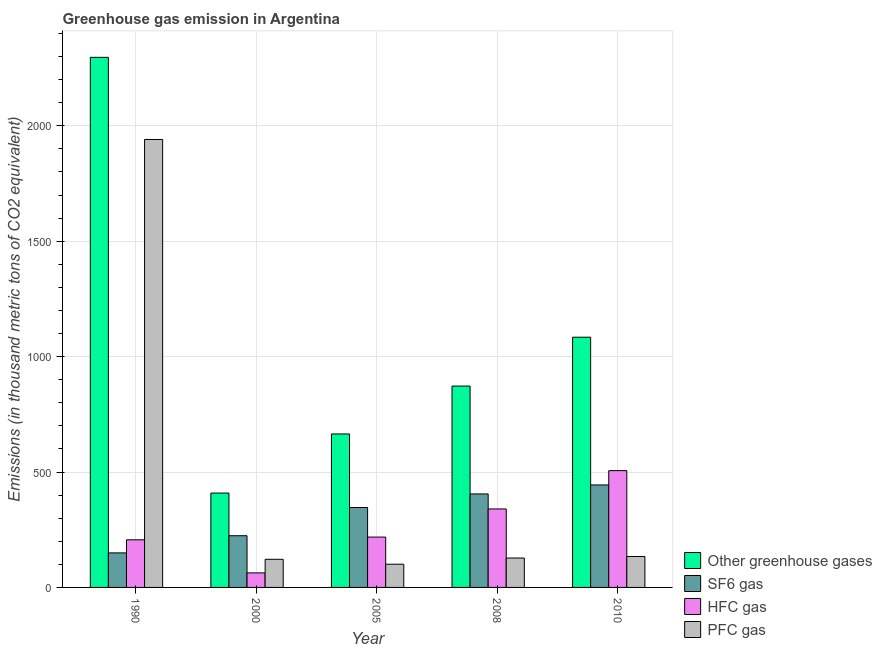How many different coloured bars are there?
Keep it short and to the point. 4. How many groups of bars are there?
Keep it short and to the point. 5. Are the number of bars per tick equal to the number of legend labels?
Your answer should be compact. Yes. What is the label of the 1st group of bars from the left?
Offer a terse response. 1990. In how many cases, is the number of bars for a given year not equal to the number of legend labels?
Your answer should be compact. 0. What is the emission of greenhouse gases in 2005?
Offer a terse response. 664.9. Across all years, what is the maximum emission of greenhouse gases?
Offer a very short reply. 2296.5. Across all years, what is the minimum emission of hfc gas?
Offer a terse response. 63. In which year was the emission of hfc gas maximum?
Provide a short and direct response. 2010. What is the total emission of sf6 gas in the graph?
Your response must be concise. 1568.8. What is the difference between the emission of pfc gas in 1990 and that in 2000?
Your answer should be very brief. 1818.8. What is the difference between the emission of sf6 gas in 2005 and the emission of greenhouse gases in 2008?
Your answer should be very brief. -58.8. What is the average emission of greenhouse gases per year?
Your response must be concise. 1065.32. In how many years, is the emission of sf6 gas greater than 2000 thousand metric tons?
Your response must be concise. 0. What is the ratio of the emission of sf6 gas in 1990 to that in 2005?
Your answer should be compact. 0.43. What is the difference between the highest and the second highest emission of pfc gas?
Offer a terse response. 1806.6. What is the difference between the highest and the lowest emission of greenhouse gases?
Your response must be concise. 1887.7. What does the 4th bar from the left in 2005 represents?
Your answer should be compact. PFC gas. What does the 3rd bar from the right in 2010 represents?
Your answer should be very brief. SF6 gas. Is it the case that in every year, the sum of the emission of greenhouse gases and emission of sf6 gas is greater than the emission of hfc gas?
Ensure brevity in your answer.  Yes. How many bars are there?
Your answer should be very brief. 20. Does the graph contain grids?
Provide a short and direct response. Yes. Where does the legend appear in the graph?
Offer a very short reply. Bottom right. How many legend labels are there?
Ensure brevity in your answer.  4. How are the legend labels stacked?
Offer a terse response. Vertical. What is the title of the graph?
Offer a very short reply. Greenhouse gas emission in Argentina. Does "Second 20% of population" appear as one of the legend labels in the graph?
Your answer should be very brief. No. What is the label or title of the X-axis?
Provide a succinct answer. Year. What is the label or title of the Y-axis?
Ensure brevity in your answer.  Emissions (in thousand metric tons of CO2 equivalent). What is the Emissions (in thousand metric tons of CO2 equivalent) in Other greenhouse gases in 1990?
Your answer should be compact. 2296.5. What is the Emissions (in thousand metric tons of CO2 equivalent) of SF6 gas in 1990?
Provide a short and direct response. 149.6. What is the Emissions (in thousand metric tons of CO2 equivalent) of HFC gas in 1990?
Provide a succinct answer. 206.3. What is the Emissions (in thousand metric tons of CO2 equivalent) of PFC gas in 1990?
Your answer should be very brief. 1940.6. What is the Emissions (in thousand metric tons of CO2 equivalent) of Other greenhouse gases in 2000?
Offer a very short reply. 408.8. What is the Emissions (in thousand metric tons of CO2 equivalent) in SF6 gas in 2000?
Your answer should be very brief. 224. What is the Emissions (in thousand metric tons of CO2 equivalent) in HFC gas in 2000?
Your response must be concise. 63. What is the Emissions (in thousand metric tons of CO2 equivalent) of PFC gas in 2000?
Your response must be concise. 121.8. What is the Emissions (in thousand metric tons of CO2 equivalent) in Other greenhouse gases in 2005?
Offer a very short reply. 664.9. What is the Emissions (in thousand metric tons of CO2 equivalent) of SF6 gas in 2005?
Offer a very short reply. 346.2. What is the Emissions (in thousand metric tons of CO2 equivalent) in HFC gas in 2005?
Make the answer very short. 218.1. What is the Emissions (in thousand metric tons of CO2 equivalent) in PFC gas in 2005?
Offer a very short reply. 100.6. What is the Emissions (in thousand metric tons of CO2 equivalent) of Other greenhouse gases in 2008?
Your response must be concise. 872.4. What is the Emissions (in thousand metric tons of CO2 equivalent) in SF6 gas in 2008?
Your answer should be compact. 405. What is the Emissions (in thousand metric tons of CO2 equivalent) of HFC gas in 2008?
Provide a succinct answer. 340. What is the Emissions (in thousand metric tons of CO2 equivalent) in PFC gas in 2008?
Provide a succinct answer. 127.4. What is the Emissions (in thousand metric tons of CO2 equivalent) of Other greenhouse gases in 2010?
Your answer should be compact. 1084. What is the Emissions (in thousand metric tons of CO2 equivalent) of SF6 gas in 2010?
Offer a terse response. 444. What is the Emissions (in thousand metric tons of CO2 equivalent) of HFC gas in 2010?
Keep it short and to the point. 506. What is the Emissions (in thousand metric tons of CO2 equivalent) of PFC gas in 2010?
Provide a short and direct response. 134. Across all years, what is the maximum Emissions (in thousand metric tons of CO2 equivalent) in Other greenhouse gases?
Offer a very short reply. 2296.5. Across all years, what is the maximum Emissions (in thousand metric tons of CO2 equivalent) in SF6 gas?
Give a very brief answer. 444. Across all years, what is the maximum Emissions (in thousand metric tons of CO2 equivalent) of HFC gas?
Your response must be concise. 506. Across all years, what is the maximum Emissions (in thousand metric tons of CO2 equivalent) of PFC gas?
Your answer should be very brief. 1940.6. Across all years, what is the minimum Emissions (in thousand metric tons of CO2 equivalent) in Other greenhouse gases?
Keep it short and to the point. 408.8. Across all years, what is the minimum Emissions (in thousand metric tons of CO2 equivalent) of SF6 gas?
Your response must be concise. 149.6. Across all years, what is the minimum Emissions (in thousand metric tons of CO2 equivalent) of PFC gas?
Offer a very short reply. 100.6. What is the total Emissions (in thousand metric tons of CO2 equivalent) of Other greenhouse gases in the graph?
Offer a very short reply. 5326.6. What is the total Emissions (in thousand metric tons of CO2 equivalent) in SF6 gas in the graph?
Offer a terse response. 1568.8. What is the total Emissions (in thousand metric tons of CO2 equivalent) in HFC gas in the graph?
Ensure brevity in your answer.  1333.4. What is the total Emissions (in thousand metric tons of CO2 equivalent) of PFC gas in the graph?
Keep it short and to the point. 2424.4. What is the difference between the Emissions (in thousand metric tons of CO2 equivalent) of Other greenhouse gases in 1990 and that in 2000?
Offer a terse response. 1887.7. What is the difference between the Emissions (in thousand metric tons of CO2 equivalent) of SF6 gas in 1990 and that in 2000?
Keep it short and to the point. -74.4. What is the difference between the Emissions (in thousand metric tons of CO2 equivalent) in HFC gas in 1990 and that in 2000?
Your answer should be compact. 143.3. What is the difference between the Emissions (in thousand metric tons of CO2 equivalent) of PFC gas in 1990 and that in 2000?
Your answer should be compact. 1818.8. What is the difference between the Emissions (in thousand metric tons of CO2 equivalent) in Other greenhouse gases in 1990 and that in 2005?
Your answer should be very brief. 1631.6. What is the difference between the Emissions (in thousand metric tons of CO2 equivalent) of SF6 gas in 1990 and that in 2005?
Your response must be concise. -196.6. What is the difference between the Emissions (in thousand metric tons of CO2 equivalent) of PFC gas in 1990 and that in 2005?
Ensure brevity in your answer.  1840. What is the difference between the Emissions (in thousand metric tons of CO2 equivalent) of Other greenhouse gases in 1990 and that in 2008?
Offer a terse response. 1424.1. What is the difference between the Emissions (in thousand metric tons of CO2 equivalent) of SF6 gas in 1990 and that in 2008?
Make the answer very short. -255.4. What is the difference between the Emissions (in thousand metric tons of CO2 equivalent) in HFC gas in 1990 and that in 2008?
Offer a terse response. -133.7. What is the difference between the Emissions (in thousand metric tons of CO2 equivalent) in PFC gas in 1990 and that in 2008?
Your answer should be very brief. 1813.2. What is the difference between the Emissions (in thousand metric tons of CO2 equivalent) of Other greenhouse gases in 1990 and that in 2010?
Ensure brevity in your answer.  1212.5. What is the difference between the Emissions (in thousand metric tons of CO2 equivalent) in SF6 gas in 1990 and that in 2010?
Ensure brevity in your answer.  -294.4. What is the difference between the Emissions (in thousand metric tons of CO2 equivalent) in HFC gas in 1990 and that in 2010?
Offer a very short reply. -299.7. What is the difference between the Emissions (in thousand metric tons of CO2 equivalent) of PFC gas in 1990 and that in 2010?
Provide a succinct answer. 1806.6. What is the difference between the Emissions (in thousand metric tons of CO2 equivalent) of Other greenhouse gases in 2000 and that in 2005?
Offer a terse response. -256.1. What is the difference between the Emissions (in thousand metric tons of CO2 equivalent) in SF6 gas in 2000 and that in 2005?
Your response must be concise. -122.2. What is the difference between the Emissions (in thousand metric tons of CO2 equivalent) in HFC gas in 2000 and that in 2005?
Ensure brevity in your answer.  -155.1. What is the difference between the Emissions (in thousand metric tons of CO2 equivalent) of PFC gas in 2000 and that in 2005?
Offer a terse response. 21.2. What is the difference between the Emissions (in thousand metric tons of CO2 equivalent) of Other greenhouse gases in 2000 and that in 2008?
Provide a succinct answer. -463.6. What is the difference between the Emissions (in thousand metric tons of CO2 equivalent) in SF6 gas in 2000 and that in 2008?
Your response must be concise. -181. What is the difference between the Emissions (in thousand metric tons of CO2 equivalent) in HFC gas in 2000 and that in 2008?
Keep it short and to the point. -277. What is the difference between the Emissions (in thousand metric tons of CO2 equivalent) in PFC gas in 2000 and that in 2008?
Provide a short and direct response. -5.6. What is the difference between the Emissions (in thousand metric tons of CO2 equivalent) in Other greenhouse gases in 2000 and that in 2010?
Your response must be concise. -675.2. What is the difference between the Emissions (in thousand metric tons of CO2 equivalent) of SF6 gas in 2000 and that in 2010?
Give a very brief answer. -220. What is the difference between the Emissions (in thousand metric tons of CO2 equivalent) in HFC gas in 2000 and that in 2010?
Your answer should be compact. -443. What is the difference between the Emissions (in thousand metric tons of CO2 equivalent) of Other greenhouse gases in 2005 and that in 2008?
Offer a terse response. -207.5. What is the difference between the Emissions (in thousand metric tons of CO2 equivalent) of SF6 gas in 2005 and that in 2008?
Your response must be concise. -58.8. What is the difference between the Emissions (in thousand metric tons of CO2 equivalent) of HFC gas in 2005 and that in 2008?
Keep it short and to the point. -121.9. What is the difference between the Emissions (in thousand metric tons of CO2 equivalent) of PFC gas in 2005 and that in 2008?
Make the answer very short. -26.8. What is the difference between the Emissions (in thousand metric tons of CO2 equivalent) in Other greenhouse gases in 2005 and that in 2010?
Your answer should be very brief. -419.1. What is the difference between the Emissions (in thousand metric tons of CO2 equivalent) in SF6 gas in 2005 and that in 2010?
Offer a terse response. -97.8. What is the difference between the Emissions (in thousand metric tons of CO2 equivalent) of HFC gas in 2005 and that in 2010?
Provide a short and direct response. -287.9. What is the difference between the Emissions (in thousand metric tons of CO2 equivalent) in PFC gas in 2005 and that in 2010?
Make the answer very short. -33.4. What is the difference between the Emissions (in thousand metric tons of CO2 equivalent) of Other greenhouse gases in 2008 and that in 2010?
Offer a very short reply. -211.6. What is the difference between the Emissions (in thousand metric tons of CO2 equivalent) in SF6 gas in 2008 and that in 2010?
Give a very brief answer. -39. What is the difference between the Emissions (in thousand metric tons of CO2 equivalent) of HFC gas in 2008 and that in 2010?
Offer a very short reply. -166. What is the difference between the Emissions (in thousand metric tons of CO2 equivalent) in Other greenhouse gases in 1990 and the Emissions (in thousand metric tons of CO2 equivalent) in SF6 gas in 2000?
Your answer should be compact. 2072.5. What is the difference between the Emissions (in thousand metric tons of CO2 equivalent) in Other greenhouse gases in 1990 and the Emissions (in thousand metric tons of CO2 equivalent) in HFC gas in 2000?
Make the answer very short. 2233.5. What is the difference between the Emissions (in thousand metric tons of CO2 equivalent) in Other greenhouse gases in 1990 and the Emissions (in thousand metric tons of CO2 equivalent) in PFC gas in 2000?
Provide a succinct answer. 2174.7. What is the difference between the Emissions (in thousand metric tons of CO2 equivalent) in SF6 gas in 1990 and the Emissions (in thousand metric tons of CO2 equivalent) in HFC gas in 2000?
Offer a terse response. 86.6. What is the difference between the Emissions (in thousand metric tons of CO2 equivalent) of SF6 gas in 1990 and the Emissions (in thousand metric tons of CO2 equivalent) of PFC gas in 2000?
Your answer should be compact. 27.8. What is the difference between the Emissions (in thousand metric tons of CO2 equivalent) of HFC gas in 1990 and the Emissions (in thousand metric tons of CO2 equivalent) of PFC gas in 2000?
Provide a succinct answer. 84.5. What is the difference between the Emissions (in thousand metric tons of CO2 equivalent) of Other greenhouse gases in 1990 and the Emissions (in thousand metric tons of CO2 equivalent) of SF6 gas in 2005?
Make the answer very short. 1950.3. What is the difference between the Emissions (in thousand metric tons of CO2 equivalent) of Other greenhouse gases in 1990 and the Emissions (in thousand metric tons of CO2 equivalent) of HFC gas in 2005?
Provide a short and direct response. 2078.4. What is the difference between the Emissions (in thousand metric tons of CO2 equivalent) of Other greenhouse gases in 1990 and the Emissions (in thousand metric tons of CO2 equivalent) of PFC gas in 2005?
Give a very brief answer. 2195.9. What is the difference between the Emissions (in thousand metric tons of CO2 equivalent) in SF6 gas in 1990 and the Emissions (in thousand metric tons of CO2 equivalent) in HFC gas in 2005?
Your answer should be very brief. -68.5. What is the difference between the Emissions (in thousand metric tons of CO2 equivalent) of HFC gas in 1990 and the Emissions (in thousand metric tons of CO2 equivalent) of PFC gas in 2005?
Make the answer very short. 105.7. What is the difference between the Emissions (in thousand metric tons of CO2 equivalent) of Other greenhouse gases in 1990 and the Emissions (in thousand metric tons of CO2 equivalent) of SF6 gas in 2008?
Offer a terse response. 1891.5. What is the difference between the Emissions (in thousand metric tons of CO2 equivalent) of Other greenhouse gases in 1990 and the Emissions (in thousand metric tons of CO2 equivalent) of HFC gas in 2008?
Your answer should be compact. 1956.5. What is the difference between the Emissions (in thousand metric tons of CO2 equivalent) of Other greenhouse gases in 1990 and the Emissions (in thousand metric tons of CO2 equivalent) of PFC gas in 2008?
Offer a terse response. 2169.1. What is the difference between the Emissions (in thousand metric tons of CO2 equivalent) of SF6 gas in 1990 and the Emissions (in thousand metric tons of CO2 equivalent) of HFC gas in 2008?
Your answer should be compact. -190.4. What is the difference between the Emissions (in thousand metric tons of CO2 equivalent) in HFC gas in 1990 and the Emissions (in thousand metric tons of CO2 equivalent) in PFC gas in 2008?
Offer a very short reply. 78.9. What is the difference between the Emissions (in thousand metric tons of CO2 equivalent) in Other greenhouse gases in 1990 and the Emissions (in thousand metric tons of CO2 equivalent) in SF6 gas in 2010?
Your answer should be compact. 1852.5. What is the difference between the Emissions (in thousand metric tons of CO2 equivalent) in Other greenhouse gases in 1990 and the Emissions (in thousand metric tons of CO2 equivalent) in HFC gas in 2010?
Keep it short and to the point. 1790.5. What is the difference between the Emissions (in thousand metric tons of CO2 equivalent) of Other greenhouse gases in 1990 and the Emissions (in thousand metric tons of CO2 equivalent) of PFC gas in 2010?
Your answer should be compact. 2162.5. What is the difference between the Emissions (in thousand metric tons of CO2 equivalent) in SF6 gas in 1990 and the Emissions (in thousand metric tons of CO2 equivalent) in HFC gas in 2010?
Your response must be concise. -356.4. What is the difference between the Emissions (in thousand metric tons of CO2 equivalent) in HFC gas in 1990 and the Emissions (in thousand metric tons of CO2 equivalent) in PFC gas in 2010?
Make the answer very short. 72.3. What is the difference between the Emissions (in thousand metric tons of CO2 equivalent) of Other greenhouse gases in 2000 and the Emissions (in thousand metric tons of CO2 equivalent) of SF6 gas in 2005?
Offer a terse response. 62.6. What is the difference between the Emissions (in thousand metric tons of CO2 equivalent) in Other greenhouse gases in 2000 and the Emissions (in thousand metric tons of CO2 equivalent) in HFC gas in 2005?
Provide a succinct answer. 190.7. What is the difference between the Emissions (in thousand metric tons of CO2 equivalent) in Other greenhouse gases in 2000 and the Emissions (in thousand metric tons of CO2 equivalent) in PFC gas in 2005?
Provide a succinct answer. 308.2. What is the difference between the Emissions (in thousand metric tons of CO2 equivalent) in SF6 gas in 2000 and the Emissions (in thousand metric tons of CO2 equivalent) in HFC gas in 2005?
Your answer should be very brief. 5.9. What is the difference between the Emissions (in thousand metric tons of CO2 equivalent) of SF6 gas in 2000 and the Emissions (in thousand metric tons of CO2 equivalent) of PFC gas in 2005?
Provide a short and direct response. 123.4. What is the difference between the Emissions (in thousand metric tons of CO2 equivalent) in HFC gas in 2000 and the Emissions (in thousand metric tons of CO2 equivalent) in PFC gas in 2005?
Give a very brief answer. -37.6. What is the difference between the Emissions (in thousand metric tons of CO2 equivalent) of Other greenhouse gases in 2000 and the Emissions (in thousand metric tons of CO2 equivalent) of HFC gas in 2008?
Provide a short and direct response. 68.8. What is the difference between the Emissions (in thousand metric tons of CO2 equivalent) in Other greenhouse gases in 2000 and the Emissions (in thousand metric tons of CO2 equivalent) in PFC gas in 2008?
Ensure brevity in your answer.  281.4. What is the difference between the Emissions (in thousand metric tons of CO2 equivalent) of SF6 gas in 2000 and the Emissions (in thousand metric tons of CO2 equivalent) of HFC gas in 2008?
Your answer should be compact. -116. What is the difference between the Emissions (in thousand metric tons of CO2 equivalent) in SF6 gas in 2000 and the Emissions (in thousand metric tons of CO2 equivalent) in PFC gas in 2008?
Provide a succinct answer. 96.6. What is the difference between the Emissions (in thousand metric tons of CO2 equivalent) in HFC gas in 2000 and the Emissions (in thousand metric tons of CO2 equivalent) in PFC gas in 2008?
Offer a terse response. -64.4. What is the difference between the Emissions (in thousand metric tons of CO2 equivalent) in Other greenhouse gases in 2000 and the Emissions (in thousand metric tons of CO2 equivalent) in SF6 gas in 2010?
Make the answer very short. -35.2. What is the difference between the Emissions (in thousand metric tons of CO2 equivalent) in Other greenhouse gases in 2000 and the Emissions (in thousand metric tons of CO2 equivalent) in HFC gas in 2010?
Offer a terse response. -97.2. What is the difference between the Emissions (in thousand metric tons of CO2 equivalent) of Other greenhouse gases in 2000 and the Emissions (in thousand metric tons of CO2 equivalent) of PFC gas in 2010?
Your response must be concise. 274.8. What is the difference between the Emissions (in thousand metric tons of CO2 equivalent) in SF6 gas in 2000 and the Emissions (in thousand metric tons of CO2 equivalent) in HFC gas in 2010?
Offer a terse response. -282. What is the difference between the Emissions (in thousand metric tons of CO2 equivalent) in SF6 gas in 2000 and the Emissions (in thousand metric tons of CO2 equivalent) in PFC gas in 2010?
Keep it short and to the point. 90. What is the difference between the Emissions (in thousand metric tons of CO2 equivalent) in HFC gas in 2000 and the Emissions (in thousand metric tons of CO2 equivalent) in PFC gas in 2010?
Make the answer very short. -71. What is the difference between the Emissions (in thousand metric tons of CO2 equivalent) in Other greenhouse gases in 2005 and the Emissions (in thousand metric tons of CO2 equivalent) in SF6 gas in 2008?
Make the answer very short. 259.9. What is the difference between the Emissions (in thousand metric tons of CO2 equivalent) in Other greenhouse gases in 2005 and the Emissions (in thousand metric tons of CO2 equivalent) in HFC gas in 2008?
Make the answer very short. 324.9. What is the difference between the Emissions (in thousand metric tons of CO2 equivalent) of Other greenhouse gases in 2005 and the Emissions (in thousand metric tons of CO2 equivalent) of PFC gas in 2008?
Offer a very short reply. 537.5. What is the difference between the Emissions (in thousand metric tons of CO2 equivalent) of SF6 gas in 2005 and the Emissions (in thousand metric tons of CO2 equivalent) of PFC gas in 2008?
Your response must be concise. 218.8. What is the difference between the Emissions (in thousand metric tons of CO2 equivalent) of HFC gas in 2005 and the Emissions (in thousand metric tons of CO2 equivalent) of PFC gas in 2008?
Offer a terse response. 90.7. What is the difference between the Emissions (in thousand metric tons of CO2 equivalent) in Other greenhouse gases in 2005 and the Emissions (in thousand metric tons of CO2 equivalent) in SF6 gas in 2010?
Offer a very short reply. 220.9. What is the difference between the Emissions (in thousand metric tons of CO2 equivalent) of Other greenhouse gases in 2005 and the Emissions (in thousand metric tons of CO2 equivalent) of HFC gas in 2010?
Provide a succinct answer. 158.9. What is the difference between the Emissions (in thousand metric tons of CO2 equivalent) in Other greenhouse gases in 2005 and the Emissions (in thousand metric tons of CO2 equivalent) in PFC gas in 2010?
Offer a very short reply. 530.9. What is the difference between the Emissions (in thousand metric tons of CO2 equivalent) of SF6 gas in 2005 and the Emissions (in thousand metric tons of CO2 equivalent) of HFC gas in 2010?
Your answer should be very brief. -159.8. What is the difference between the Emissions (in thousand metric tons of CO2 equivalent) in SF6 gas in 2005 and the Emissions (in thousand metric tons of CO2 equivalent) in PFC gas in 2010?
Your answer should be compact. 212.2. What is the difference between the Emissions (in thousand metric tons of CO2 equivalent) in HFC gas in 2005 and the Emissions (in thousand metric tons of CO2 equivalent) in PFC gas in 2010?
Provide a succinct answer. 84.1. What is the difference between the Emissions (in thousand metric tons of CO2 equivalent) in Other greenhouse gases in 2008 and the Emissions (in thousand metric tons of CO2 equivalent) in SF6 gas in 2010?
Your response must be concise. 428.4. What is the difference between the Emissions (in thousand metric tons of CO2 equivalent) in Other greenhouse gases in 2008 and the Emissions (in thousand metric tons of CO2 equivalent) in HFC gas in 2010?
Your answer should be compact. 366.4. What is the difference between the Emissions (in thousand metric tons of CO2 equivalent) in Other greenhouse gases in 2008 and the Emissions (in thousand metric tons of CO2 equivalent) in PFC gas in 2010?
Your answer should be compact. 738.4. What is the difference between the Emissions (in thousand metric tons of CO2 equivalent) in SF6 gas in 2008 and the Emissions (in thousand metric tons of CO2 equivalent) in HFC gas in 2010?
Make the answer very short. -101. What is the difference between the Emissions (in thousand metric tons of CO2 equivalent) of SF6 gas in 2008 and the Emissions (in thousand metric tons of CO2 equivalent) of PFC gas in 2010?
Your answer should be compact. 271. What is the difference between the Emissions (in thousand metric tons of CO2 equivalent) in HFC gas in 2008 and the Emissions (in thousand metric tons of CO2 equivalent) in PFC gas in 2010?
Offer a terse response. 206. What is the average Emissions (in thousand metric tons of CO2 equivalent) of Other greenhouse gases per year?
Your answer should be compact. 1065.32. What is the average Emissions (in thousand metric tons of CO2 equivalent) in SF6 gas per year?
Give a very brief answer. 313.76. What is the average Emissions (in thousand metric tons of CO2 equivalent) in HFC gas per year?
Make the answer very short. 266.68. What is the average Emissions (in thousand metric tons of CO2 equivalent) in PFC gas per year?
Provide a short and direct response. 484.88. In the year 1990, what is the difference between the Emissions (in thousand metric tons of CO2 equivalent) in Other greenhouse gases and Emissions (in thousand metric tons of CO2 equivalent) in SF6 gas?
Provide a short and direct response. 2146.9. In the year 1990, what is the difference between the Emissions (in thousand metric tons of CO2 equivalent) of Other greenhouse gases and Emissions (in thousand metric tons of CO2 equivalent) of HFC gas?
Provide a short and direct response. 2090.2. In the year 1990, what is the difference between the Emissions (in thousand metric tons of CO2 equivalent) of Other greenhouse gases and Emissions (in thousand metric tons of CO2 equivalent) of PFC gas?
Your answer should be very brief. 355.9. In the year 1990, what is the difference between the Emissions (in thousand metric tons of CO2 equivalent) of SF6 gas and Emissions (in thousand metric tons of CO2 equivalent) of HFC gas?
Provide a short and direct response. -56.7. In the year 1990, what is the difference between the Emissions (in thousand metric tons of CO2 equivalent) of SF6 gas and Emissions (in thousand metric tons of CO2 equivalent) of PFC gas?
Provide a succinct answer. -1791. In the year 1990, what is the difference between the Emissions (in thousand metric tons of CO2 equivalent) of HFC gas and Emissions (in thousand metric tons of CO2 equivalent) of PFC gas?
Your answer should be very brief. -1734.3. In the year 2000, what is the difference between the Emissions (in thousand metric tons of CO2 equivalent) in Other greenhouse gases and Emissions (in thousand metric tons of CO2 equivalent) in SF6 gas?
Your answer should be very brief. 184.8. In the year 2000, what is the difference between the Emissions (in thousand metric tons of CO2 equivalent) of Other greenhouse gases and Emissions (in thousand metric tons of CO2 equivalent) of HFC gas?
Your answer should be compact. 345.8. In the year 2000, what is the difference between the Emissions (in thousand metric tons of CO2 equivalent) in Other greenhouse gases and Emissions (in thousand metric tons of CO2 equivalent) in PFC gas?
Give a very brief answer. 287. In the year 2000, what is the difference between the Emissions (in thousand metric tons of CO2 equivalent) of SF6 gas and Emissions (in thousand metric tons of CO2 equivalent) of HFC gas?
Offer a terse response. 161. In the year 2000, what is the difference between the Emissions (in thousand metric tons of CO2 equivalent) in SF6 gas and Emissions (in thousand metric tons of CO2 equivalent) in PFC gas?
Your answer should be very brief. 102.2. In the year 2000, what is the difference between the Emissions (in thousand metric tons of CO2 equivalent) in HFC gas and Emissions (in thousand metric tons of CO2 equivalent) in PFC gas?
Your answer should be compact. -58.8. In the year 2005, what is the difference between the Emissions (in thousand metric tons of CO2 equivalent) in Other greenhouse gases and Emissions (in thousand metric tons of CO2 equivalent) in SF6 gas?
Provide a succinct answer. 318.7. In the year 2005, what is the difference between the Emissions (in thousand metric tons of CO2 equivalent) of Other greenhouse gases and Emissions (in thousand metric tons of CO2 equivalent) of HFC gas?
Your response must be concise. 446.8. In the year 2005, what is the difference between the Emissions (in thousand metric tons of CO2 equivalent) in Other greenhouse gases and Emissions (in thousand metric tons of CO2 equivalent) in PFC gas?
Your answer should be compact. 564.3. In the year 2005, what is the difference between the Emissions (in thousand metric tons of CO2 equivalent) of SF6 gas and Emissions (in thousand metric tons of CO2 equivalent) of HFC gas?
Give a very brief answer. 128.1. In the year 2005, what is the difference between the Emissions (in thousand metric tons of CO2 equivalent) of SF6 gas and Emissions (in thousand metric tons of CO2 equivalent) of PFC gas?
Ensure brevity in your answer.  245.6. In the year 2005, what is the difference between the Emissions (in thousand metric tons of CO2 equivalent) of HFC gas and Emissions (in thousand metric tons of CO2 equivalent) of PFC gas?
Your answer should be compact. 117.5. In the year 2008, what is the difference between the Emissions (in thousand metric tons of CO2 equivalent) of Other greenhouse gases and Emissions (in thousand metric tons of CO2 equivalent) of SF6 gas?
Keep it short and to the point. 467.4. In the year 2008, what is the difference between the Emissions (in thousand metric tons of CO2 equivalent) of Other greenhouse gases and Emissions (in thousand metric tons of CO2 equivalent) of HFC gas?
Ensure brevity in your answer.  532.4. In the year 2008, what is the difference between the Emissions (in thousand metric tons of CO2 equivalent) of Other greenhouse gases and Emissions (in thousand metric tons of CO2 equivalent) of PFC gas?
Offer a very short reply. 745. In the year 2008, what is the difference between the Emissions (in thousand metric tons of CO2 equivalent) in SF6 gas and Emissions (in thousand metric tons of CO2 equivalent) in PFC gas?
Your response must be concise. 277.6. In the year 2008, what is the difference between the Emissions (in thousand metric tons of CO2 equivalent) of HFC gas and Emissions (in thousand metric tons of CO2 equivalent) of PFC gas?
Offer a very short reply. 212.6. In the year 2010, what is the difference between the Emissions (in thousand metric tons of CO2 equivalent) in Other greenhouse gases and Emissions (in thousand metric tons of CO2 equivalent) in SF6 gas?
Offer a terse response. 640. In the year 2010, what is the difference between the Emissions (in thousand metric tons of CO2 equivalent) of Other greenhouse gases and Emissions (in thousand metric tons of CO2 equivalent) of HFC gas?
Give a very brief answer. 578. In the year 2010, what is the difference between the Emissions (in thousand metric tons of CO2 equivalent) of Other greenhouse gases and Emissions (in thousand metric tons of CO2 equivalent) of PFC gas?
Your answer should be very brief. 950. In the year 2010, what is the difference between the Emissions (in thousand metric tons of CO2 equivalent) of SF6 gas and Emissions (in thousand metric tons of CO2 equivalent) of HFC gas?
Keep it short and to the point. -62. In the year 2010, what is the difference between the Emissions (in thousand metric tons of CO2 equivalent) in SF6 gas and Emissions (in thousand metric tons of CO2 equivalent) in PFC gas?
Your response must be concise. 310. In the year 2010, what is the difference between the Emissions (in thousand metric tons of CO2 equivalent) of HFC gas and Emissions (in thousand metric tons of CO2 equivalent) of PFC gas?
Your answer should be very brief. 372. What is the ratio of the Emissions (in thousand metric tons of CO2 equivalent) in Other greenhouse gases in 1990 to that in 2000?
Make the answer very short. 5.62. What is the ratio of the Emissions (in thousand metric tons of CO2 equivalent) of SF6 gas in 1990 to that in 2000?
Offer a very short reply. 0.67. What is the ratio of the Emissions (in thousand metric tons of CO2 equivalent) in HFC gas in 1990 to that in 2000?
Your response must be concise. 3.27. What is the ratio of the Emissions (in thousand metric tons of CO2 equivalent) of PFC gas in 1990 to that in 2000?
Give a very brief answer. 15.93. What is the ratio of the Emissions (in thousand metric tons of CO2 equivalent) in Other greenhouse gases in 1990 to that in 2005?
Ensure brevity in your answer.  3.45. What is the ratio of the Emissions (in thousand metric tons of CO2 equivalent) of SF6 gas in 1990 to that in 2005?
Offer a terse response. 0.43. What is the ratio of the Emissions (in thousand metric tons of CO2 equivalent) in HFC gas in 1990 to that in 2005?
Your response must be concise. 0.95. What is the ratio of the Emissions (in thousand metric tons of CO2 equivalent) in PFC gas in 1990 to that in 2005?
Give a very brief answer. 19.29. What is the ratio of the Emissions (in thousand metric tons of CO2 equivalent) of Other greenhouse gases in 1990 to that in 2008?
Your answer should be compact. 2.63. What is the ratio of the Emissions (in thousand metric tons of CO2 equivalent) of SF6 gas in 1990 to that in 2008?
Offer a very short reply. 0.37. What is the ratio of the Emissions (in thousand metric tons of CO2 equivalent) in HFC gas in 1990 to that in 2008?
Offer a very short reply. 0.61. What is the ratio of the Emissions (in thousand metric tons of CO2 equivalent) in PFC gas in 1990 to that in 2008?
Your response must be concise. 15.23. What is the ratio of the Emissions (in thousand metric tons of CO2 equivalent) of Other greenhouse gases in 1990 to that in 2010?
Your response must be concise. 2.12. What is the ratio of the Emissions (in thousand metric tons of CO2 equivalent) in SF6 gas in 1990 to that in 2010?
Ensure brevity in your answer.  0.34. What is the ratio of the Emissions (in thousand metric tons of CO2 equivalent) in HFC gas in 1990 to that in 2010?
Make the answer very short. 0.41. What is the ratio of the Emissions (in thousand metric tons of CO2 equivalent) in PFC gas in 1990 to that in 2010?
Provide a succinct answer. 14.48. What is the ratio of the Emissions (in thousand metric tons of CO2 equivalent) in Other greenhouse gases in 2000 to that in 2005?
Offer a terse response. 0.61. What is the ratio of the Emissions (in thousand metric tons of CO2 equivalent) in SF6 gas in 2000 to that in 2005?
Provide a short and direct response. 0.65. What is the ratio of the Emissions (in thousand metric tons of CO2 equivalent) of HFC gas in 2000 to that in 2005?
Provide a succinct answer. 0.29. What is the ratio of the Emissions (in thousand metric tons of CO2 equivalent) of PFC gas in 2000 to that in 2005?
Ensure brevity in your answer.  1.21. What is the ratio of the Emissions (in thousand metric tons of CO2 equivalent) of Other greenhouse gases in 2000 to that in 2008?
Offer a terse response. 0.47. What is the ratio of the Emissions (in thousand metric tons of CO2 equivalent) of SF6 gas in 2000 to that in 2008?
Ensure brevity in your answer.  0.55. What is the ratio of the Emissions (in thousand metric tons of CO2 equivalent) in HFC gas in 2000 to that in 2008?
Provide a succinct answer. 0.19. What is the ratio of the Emissions (in thousand metric tons of CO2 equivalent) of PFC gas in 2000 to that in 2008?
Provide a short and direct response. 0.96. What is the ratio of the Emissions (in thousand metric tons of CO2 equivalent) in Other greenhouse gases in 2000 to that in 2010?
Give a very brief answer. 0.38. What is the ratio of the Emissions (in thousand metric tons of CO2 equivalent) of SF6 gas in 2000 to that in 2010?
Make the answer very short. 0.5. What is the ratio of the Emissions (in thousand metric tons of CO2 equivalent) in HFC gas in 2000 to that in 2010?
Provide a short and direct response. 0.12. What is the ratio of the Emissions (in thousand metric tons of CO2 equivalent) of PFC gas in 2000 to that in 2010?
Keep it short and to the point. 0.91. What is the ratio of the Emissions (in thousand metric tons of CO2 equivalent) in Other greenhouse gases in 2005 to that in 2008?
Offer a terse response. 0.76. What is the ratio of the Emissions (in thousand metric tons of CO2 equivalent) in SF6 gas in 2005 to that in 2008?
Offer a very short reply. 0.85. What is the ratio of the Emissions (in thousand metric tons of CO2 equivalent) of HFC gas in 2005 to that in 2008?
Ensure brevity in your answer.  0.64. What is the ratio of the Emissions (in thousand metric tons of CO2 equivalent) in PFC gas in 2005 to that in 2008?
Your response must be concise. 0.79. What is the ratio of the Emissions (in thousand metric tons of CO2 equivalent) in Other greenhouse gases in 2005 to that in 2010?
Provide a short and direct response. 0.61. What is the ratio of the Emissions (in thousand metric tons of CO2 equivalent) in SF6 gas in 2005 to that in 2010?
Your response must be concise. 0.78. What is the ratio of the Emissions (in thousand metric tons of CO2 equivalent) in HFC gas in 2005 to that in 2010?
Provide a succinct answer. 0.43. What is the ratio of the Emissions (in thousand metric tons of CO2 equivalent) of PFC gas in 2005 to that in 2010?
Offer a terse response. 0.75. What is the ratio of the Emissions (in thousand metric tons of CO2 equivalent) in Other greenhouse gases in 2008 to that in 2010?
Provide a succinct answer. 0.8. What is the ratio of the Emissions (in thousand metric tons of CO2 equivalent) of SF6 gas in 2008 to that in 2010?
Give a very brief answer. 0.91. What is the ratio of the Emissions (in thousand metric tons of CO2 equivalent) of HFC gas in 2008 to that in 2010?
Ensure brevity in your answer.  0.67. What is the ratio of the Emissions (in thousand metric tons of CO2 equivalent) in PFC gas in 2008 to that in 2010?
Provide a succinct answer. 0.95. What is the difference between the highest and the second highest Emissions (in thousand metric tons of CO2 equivalent) in Other greenhouse gases?
Provide a succinct answer. 1212.5. What is the difference between the highest and the second highest Emissions (in thousand metric tons of CO2 equivalent) in HFC gas?
Offer a terse response. 166. What is the difference between the highest and the second highest Emissions (in thousand metric tons of CO2 equivalent) in PFC gas?
Your answer should be compact. 1806.6. What is the difference between the highest and the lowest Emissions (in thousand metric tons of CO2 equivalent) in Other greenhouse gases?
Your answer should be compact. 1887.7. What is the difference between the highest and the lowest Emissions (in thousand metric tons of CO2 equivalent) of SF6 gas?
Give a very brief answer. 294.4. What is the difference between the highest and the lowest Emissions (in thousand metric tons of CO2 equivalent) of HFC gas?
Your answer should be very brief. 443. What is the difference between the highest and the lowest Emissions (in thousand metric tons of CO2 equivalent) of PFC gas?
Your answer should be very brief. 1840. 